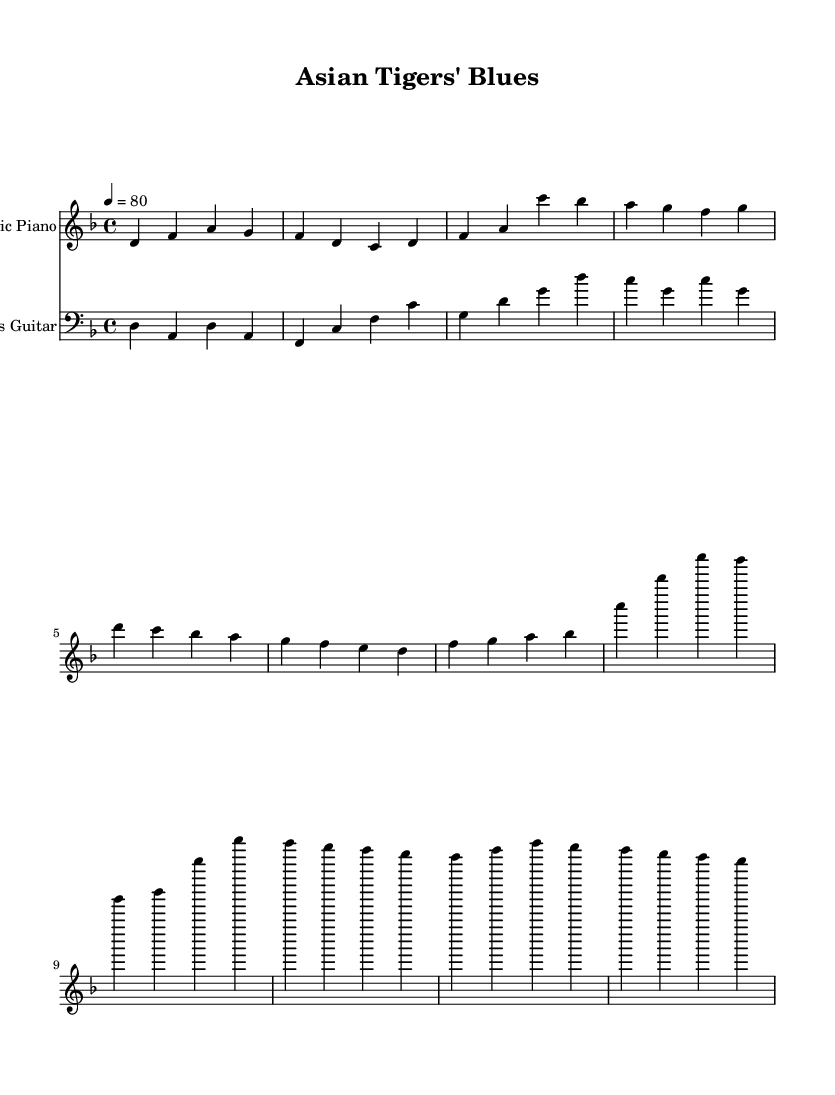What is the key signature of this music? The key signature shows two flats, which indicates it is in the key of D minor. In D minor, the notes that are naturally found are D, E, F, G, A, B♭, and C. The presence of the flats (B♭ and E♭) confirms this key signature.
Answer: D minor What is the time signature of this piece? The time signature is located at the beginning of the staff and is shown as 4/4, meaning there are four beats in each measure and the quarter note gets one beat. This is a common time signature that typically indicates a steady pulse, fitting for R&B music.
Answer: 4/4 What is the tempo marking of this music? The tempo marking indicates that this piece should be played at a speed of 80 beats per minute, which is noted at the beginning with "4 = 80." This gives the performer guidance on how fast to play the music.
Answer: 80 How many measures are there in the electric piano part? Counting the group of four-note segments (measures) in the electric piano part, there are a total of six measures. Each measure is separated by a bar line, which allows for easy counting.
Answer: Six Which instruments are included in this sheet music? This sheet music features two instruments as indicated at the top of each staff: an Electric Piano and a Bass Guitar. This instrumentation is typical for creating a rich sound in Rhythm and Blues arrangements.
Answer: Electric Piano and Bass Guitar What is the most repeated note in the bass guitar part? In the bass guitar part, the note D is played repeatedly in the first measure and appears in each subsequent alternating measure, indicating it’s the foundational note of the bass line.
Answer: D 